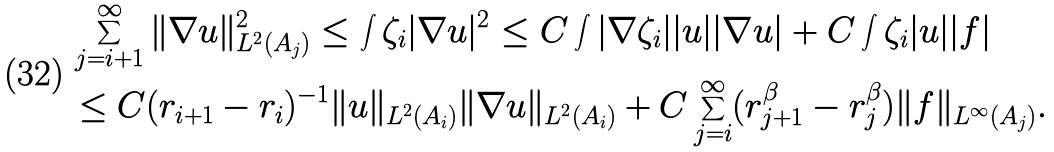Convert formula to latex. <formula><loc_0><loc_0><loc_500><loc_500>& \sum _ { j = i + 1 } ^ { \infty } \| \nabla u \| _ { L ^ { 2 } ( A _ { j } ) } ^ { 2 } \leq \int \zeta _ { i } | \nabla u | ^ { 2 } \leq C \int | \nabla \zeta _ { i } | | u | | \nabla u | + C \int \zeta _ { i } | u | | f | \\ & \leq C ( r _ { i + 1 } - r _ { i } ) ^ { - 1 } \| u \| _ { L ^ { 2 } ( A _ { i } ) } \| \nabla u \| _ { L ^ { 2 } ( A _ { i } ) } + C \sum _ { j = i } ^ { \infty } ( r _ { j + 1 } ^ { \beta } - r _ { j } ^ { \beta } ) \| f \| _ { L ^ { \infty } ( A _ { j } ) } .</formula> 